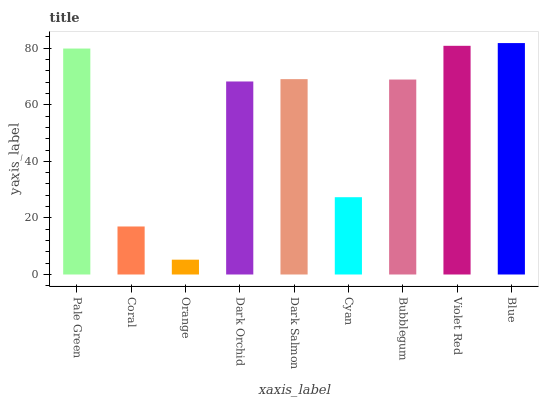Is Orange the minimum?
Answer yes or no. Yes. Is Blue the maximum?
Answer yes or no. Yes. Is Coral the minimum?
Answer yes or no. No. Is Coral the maximum?
Answer yes or no. No. Is Pale Green greater than Coral?
Answer yes or no. Yes. Is Coral less than Pale Green?
Answer yes or no. Yes. Is Coral greater than Pale Green?
Answer yes or no. No. Is Pale Green less than Coral?
Answer yes or no. No. Is Bubblegum the high median?
Answer yes or no. Yes. Is Bubblegum the low median?
Answer yes or no. Yes. Is Pale Green the high median?
Answer yes or no. No. Is Pale Green the low median?
Answer yes or no. No. 